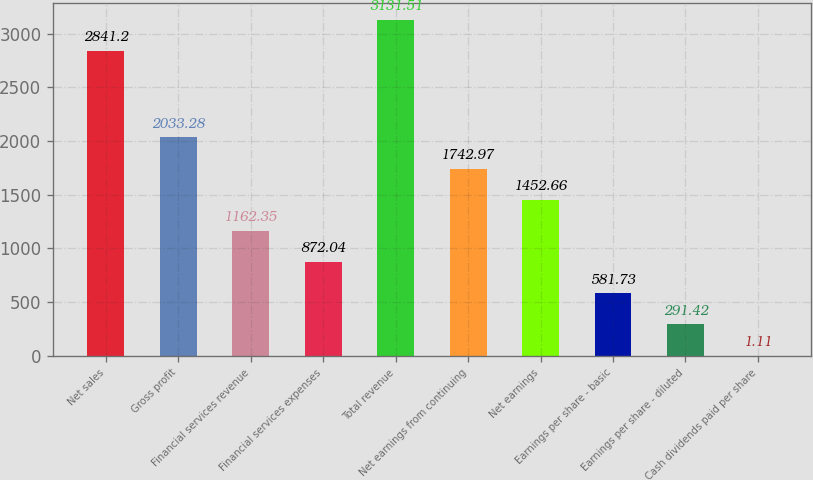Convert chart to OTSL. <chart><loc_0><loc_0><loc_500><loc_500><bar_chart><fcel>Net sales<fcel>Gross profit<fcel>Financial services revenue<fcel>Financial services expenses<fcel>Total revenue<fcel>Net earnings from continuing<fcel>Net earnings<fcel>Earnings per share - basic<fcel>Earnings per share - diluted<fcel>Cash dividends paid per share<nl><fcel>2841.2<fcel>2033.28<fcel>1162.35<fcel>872.04<fcel>3131.51<fcel>1742.97<fcel>1452.66<fcel>581.73<fcel>291.42<fcel>1.11<nl></chart> 